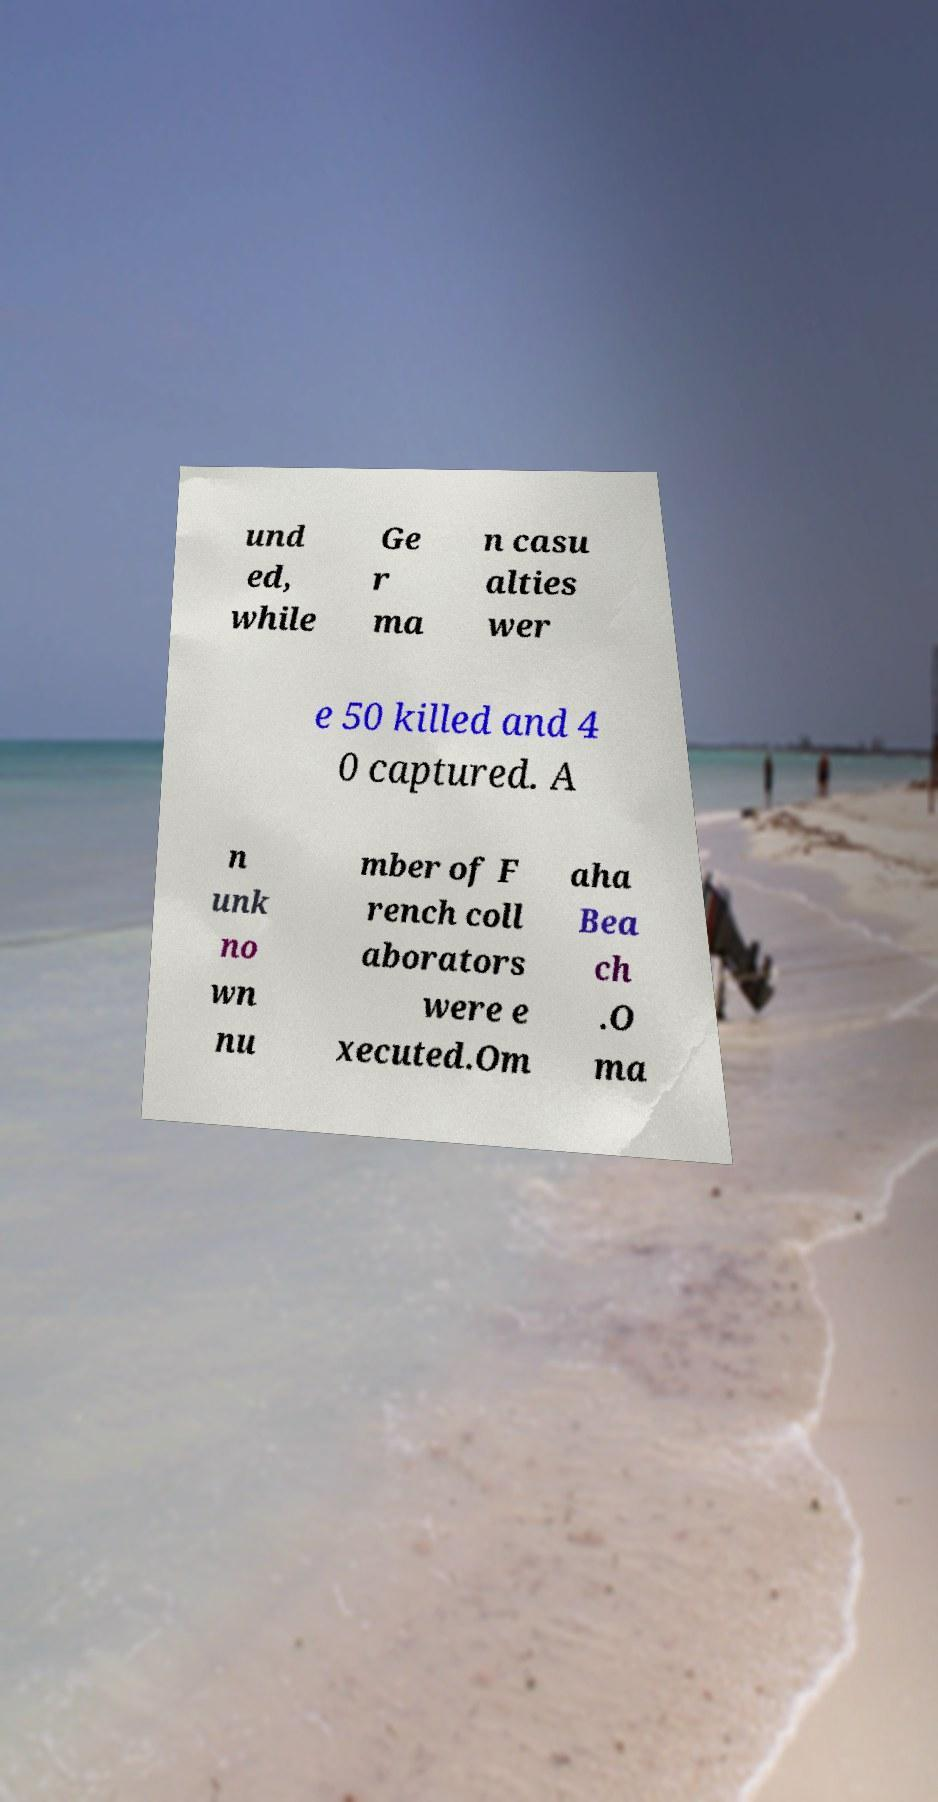Can you accurately transcribe the text from the provided image for me? und ed, while Ge r ma n casu alties wer e 50 killed and 4 0 captured. A n unk no wn nu mber of F rench coll aborators were e xecuted.Om aha Bea ch .O ma 